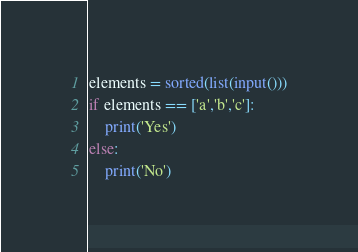Convert code to text. <code><loc_0><loc_0><loc_500><loc_500><_Python_>elements = sorted(list(input()))
if elements == ['a','b','c']:
	print('Yes')
else:
	print('No')</code> 